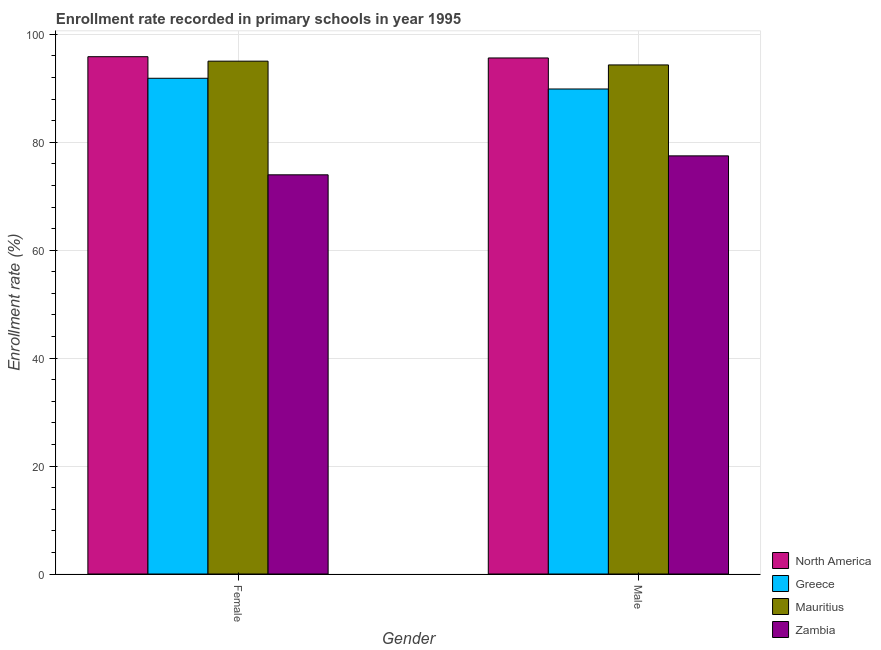How many different coloured bars are there?
Keep it short and to the point. 4. How many bars are there on the 2nd tick from the left?
Keep it short and to the point. 4. What is the enrollment rate of male students in Zambia?
Provide a succinct answer. 77.49. Across all countries, what is the maximum enrollment rate of male students?
Give a very brief answer. 95.63. Across all countries, what is the minimum enrollment rate of female students?
Your answer should be compact. 73.97. In which country was the enrollment rate of male students maximum?
Your answer should be compact. North America. In which country was the enrollment rate of female students minimum?
Keep it short and to the point. Zambia. What is the total enrollment rate of male students in the graph?
Provide a succinct answer. 357.33. What is the difference between the enrollment rate of female students in Zambia and that in North America?
Offer a very short reply. -21.89. What is the difference between the enrollment rate of female students in Mauritius and the enrollment rate of male students in North America?
Give a very brief answer. -0.59. What is the average enrollment rate of male students per country?
Offer a terse response. 89.33. What is the difference between the enrollment rate of male students and enrollment rate of female students in Zambia?
Ensure brevity in your answer.  3.51. In how many countries, is the enrollment rate of female students greater than 48 %?
Provide a short and direct response. 4. What is the ratio of the enrollment rate of female students in Mauritius to that in North America?
Offer a terse response. 0.99. Is the enrollment rate of female students in Greece less than that in Mauritius?
Give a very brief answer. Yes. What does the 2nd bar from the left in Female represents?
Offer a very short reply. Greece. What does the 2nd bar from the right in Male represents?
Keep it short and to the point. Mauritius. Does the graph contain any zero values?
Make the answer very short. No. Does the graph contain grids?
Make the answer very short. Yes. How many legend labels are there?
Give a very brief answer. 4. What is the title of the graph?
Your response must be concise. Enrollment rate recorded in primary schools in year 1995. Does "Latin America(developing only)" appear as one of the legend labels in the graph?
Your response must be concise. No. What is the label or title of the X-axis?
Keep it short and to the point. Gender. What is the label or title of the Y-axis?
Keep it short and to the point. Enrollment rate (%). What is the Enrollment rate (%) in North America in Female?
Make the answer very short. 95.87. What is the Enrollment rate (%) of Greece in Female?
Your response must be concise. 91.86. What is the Enrollment rate (%) of Mauritius in Female?
Offer a terse response. 95.04. What is the Enrollment rate (%) of Zambia in Female?
Keep it short and to the point. 73.97. What is the Enrollment rate (%) in North America in Male?
Offer a terse response. 95.63. What is the Enrollment rate (%) of Greece in Male?
Provide a succinct answer. 89.88. What is the Enrollment rate (%) in Mauritius in Male?
Keep it short and to the point. 94.34. What is the Enrollment rate (%) in Zambia in Male?
Keep it short and to the point. 77.49. Across all Gender, what is the maximum Enrollment rate (%) of North America?
Your response must be concise. 95.87. Across all Gender, what is the maximum Enrollment rate (%) of Greece?
Offer a terse response. 91.86. Across all Gender, what is the maximum Enrollment rate (%) of Mauritius?
Your answer should be compact. 95.04. Across all Gender, what is the maximum Enrollment rate (%) of Zambia?
Provide a short and direct response. 77.49. Across all Gender, what is the minimum Enrollment rate (%) in North America?
Offer a very short reply. 95.63. Across all Gender, what is the minimum Enrollment rate (%) of Greece?
Offer a terse response. 89.88. Across all Gender, what is the minimum Enrollment rate (%) in Mauritius?
Offer a terse response. 94.34. Across all Gender, what is the minimum Enrollment rate (%) of Zambia?
Ensure brevity in your answer.  73.97. What is the total Enrollment rate (%) of North America in the graph?
Provide a succinct answer. 191.49. What is the total Enrollment rate (%) of Greece in the graph?
Provide a short and direct response. 181.74. What is the total Enrollment rate (%) in Mauritius in the graph?
Provide a short and direct response. 189.37. What is the total Enrollment rate (%) in Zambia in the graph?
Ensure brevity in your answer.  151.46. What is the difference between the Enrollment rate (%) in North America in Female and that in Male?
Make the answer very short. 0.24. What is the difference between the Enrollment rate (%) in Greece in Female and that in Male?
Your response must be concise. 1.99. What is the difference between the Enrollment rate (%) of Mauritius in Female and that in Male?
Provide a succinct answer. 0.7. What is the difference between the Enrollment rate (%) of Zambia in Female and that in Male?
Offer a very short reply. -3.51. What is the difference between the Enrollment rate (%) in North America in Female and the Enrollment rate (%) in Greece in Male?
Make the answer very short. 5.99. What is the difference between the Enrollment rate (%) of North America in Female and the Enrollment rate (%) of Mauritius in Male?
Offer a terse response. 1.53. What is the difference between the Enrollment rate (%) in North America in Female and the Enrollment rate (%) in Zambia in Male?
Make the answer very short. 18.38. What is the difference between the Enrollment rate (%) of Greece in Female and the Enrollment rate (%) of Mauritius in Male?
Your response must be concise. -2.47. What is the difference between the Enrollment rate (%) in Greece in Female and the Enrollment rate (%) in Zambia in Male?
Your response must be concise. 14.38. What is the difference between the Enrollment rate (%) in Mauritius in Female and the Enrollment rate (%) in Zambia in Male?
Offer a terse response. 17.55. What is the average Enrollment rate (%) in North America per Gender?
Make the answer very short. 95.75. What is the average Enrollment rate (%) in Greece per Gender?
Give a very brief answer. 90.87. What is the average Enrollment rate (%) of Mauritius per Gender?
Provide a short and direct response. 94.69. What is the average Enrollment rate (%) of Zambia per Gender?
Offer a very short reply. 75.73. What is the difference between the Enrollment rate (%) in North America and Enrollment rate (%) in Greece in Female?
Your answer should be compact. 4. What is the difference between the Enrollment rate (%) of North America and Enrollment rate (%) of Mauritius in Female?
Give a very brief answer. 0.83. What is the difference between the Enrollment rate (%) in North America and Enrollment rate (%) in Zambia in Female?
Give a very brief answer. 21.89. What is the difference between the Enrollment rate (%) of Greece and Enrollment rate (%) of Mauritius in Female?
Ensure brevity in your answer.  -3.17. What is the difference between the Enrollment rate (%) of Greece and Enrollment rate (%) of Zambia in Female?
Your answer should be very brief. 17.89. What is the difference between the Enrollment rate (%) of Mauritius and Enrollment rate (%) of Zambia in Female?
Provide a short and direct response. 21.06. What is the difference between the Enrollment rate (%) of North America and Enrollment rate (%) of Greece in Male?
Offer a terse response. 5.75. What is the difference between the Enrollment rate (%) in North America and Enrollment rate (%) in Mauritius in Male?
Provide a succinct answer. 1.29. What is the difference between the Enrollment rate (%) of North America and Enrollment rate (%) of Zambia in Male?
Offer a terse response. 18.14. What is the difference between the Enrollment rate (%) of Greece and Enrollment rate (%) of Mauritius in Male?
Offer a terse response. -4.46. What is the difference between the Enrollment rate (%) in Greece and Enrollment rate (%) in Zambia in Male?
Provide a short and direct response. 12.39. What is the difference between the Enrollment rate (%) in Mauritius and Enrollment rate (%) in Zambia in Male?
Your answer should be very brief. 16.85. What is the ratio of the Enrollment rate (%) in North America in Female to that in Male?
Provide a succinct answer. 1. What is the ratio of the Enrollment rate (%) of Greece in Female to that in Male?
Your answer should be very brief. 1.02. What is the ratio of the Enrollment rate (%) in Mauritius in Female to that in Male?
Provide a short and direct response. 1.01. What is the ratio of the Enrollment rate (%) in Zambia in Female to that in Male?
Your answer should be very brief. 0.95. What is the difference between the highest and the second highest Enrollment rate (%) in North America?
Make the answer very short. 0.24. What is the difference between the highest and the second highest Enrollment rate (%) in Greece?
Give a very brief answer. 1.99. What is the difference between the highest and the second highest Enrollment rate (%) in Mauritius?
Make the answer very short. 0.7. What is the difference between the highest and the second highest Enrollment rate (%) in Zambia?
Offer a terse response. 3.51. What is the difference between the highest and the lowest Enrollment rate (%) in North America?
Your answer should be very brief. 0.24. What is the difference between the highest and the lowest Enrollment rate (%) of Greece?
Offer a very short reply. 1.99. What is the difference between the highest and the lowest Enrollment rate (%) in Mauritius?
Your answer should be very brief. 0.7. What is the difference between the highest and the lowest Enrollment rate (%) in Zambia?
Offer a terse response. 3.51. 